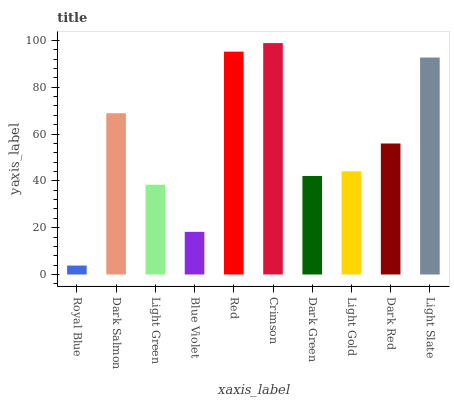Is Royal Blue the minimum?
Answer yes or no. Yes. Is Crimson the maximum?
Answer yes or no. Yes. Is Dark Salmon the minimum?
Answer yes or no. No. Is Dark Salmon the maximum?
Answer yes or no. No. Is Dark Salmon greater than Royal Blue?
Answer yes or no. Yes. Is Royal Blue less than Dark Salmon?
Answer yes or no. Yes. Is Royal Blue greater than Dark Salmon?
Answer yes or no. No. Is Dark Salmon less than Royal Blue?
Answer yes or no. No. Is Dark Red the high median?
Answer yes or no. Yes. Is Light Gold the low median?
Answer yes or no. Yes. Is Blue Violet the high median?
Answer yes or no. No. Is Light Green the low median?
Answer yes or no. No. 